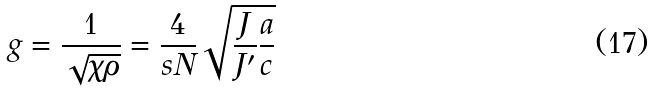<formula> <loc_0><loc_0><loc_500><loc_500>g = \frac { 1 } { \sqrt { \chi \rho } } = \frac { 4 } { s N } \sqrt { \frac { J } { J ^ { \prime } } \frac { a } { c } }</formula> 